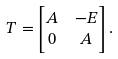Convert formula to latex. <formula><loc_0><loc_0><loc_500><loc_500>T & = \begin{bmatrix} A & - E \\ 0 & A \end{bmatrix} .</formula> 